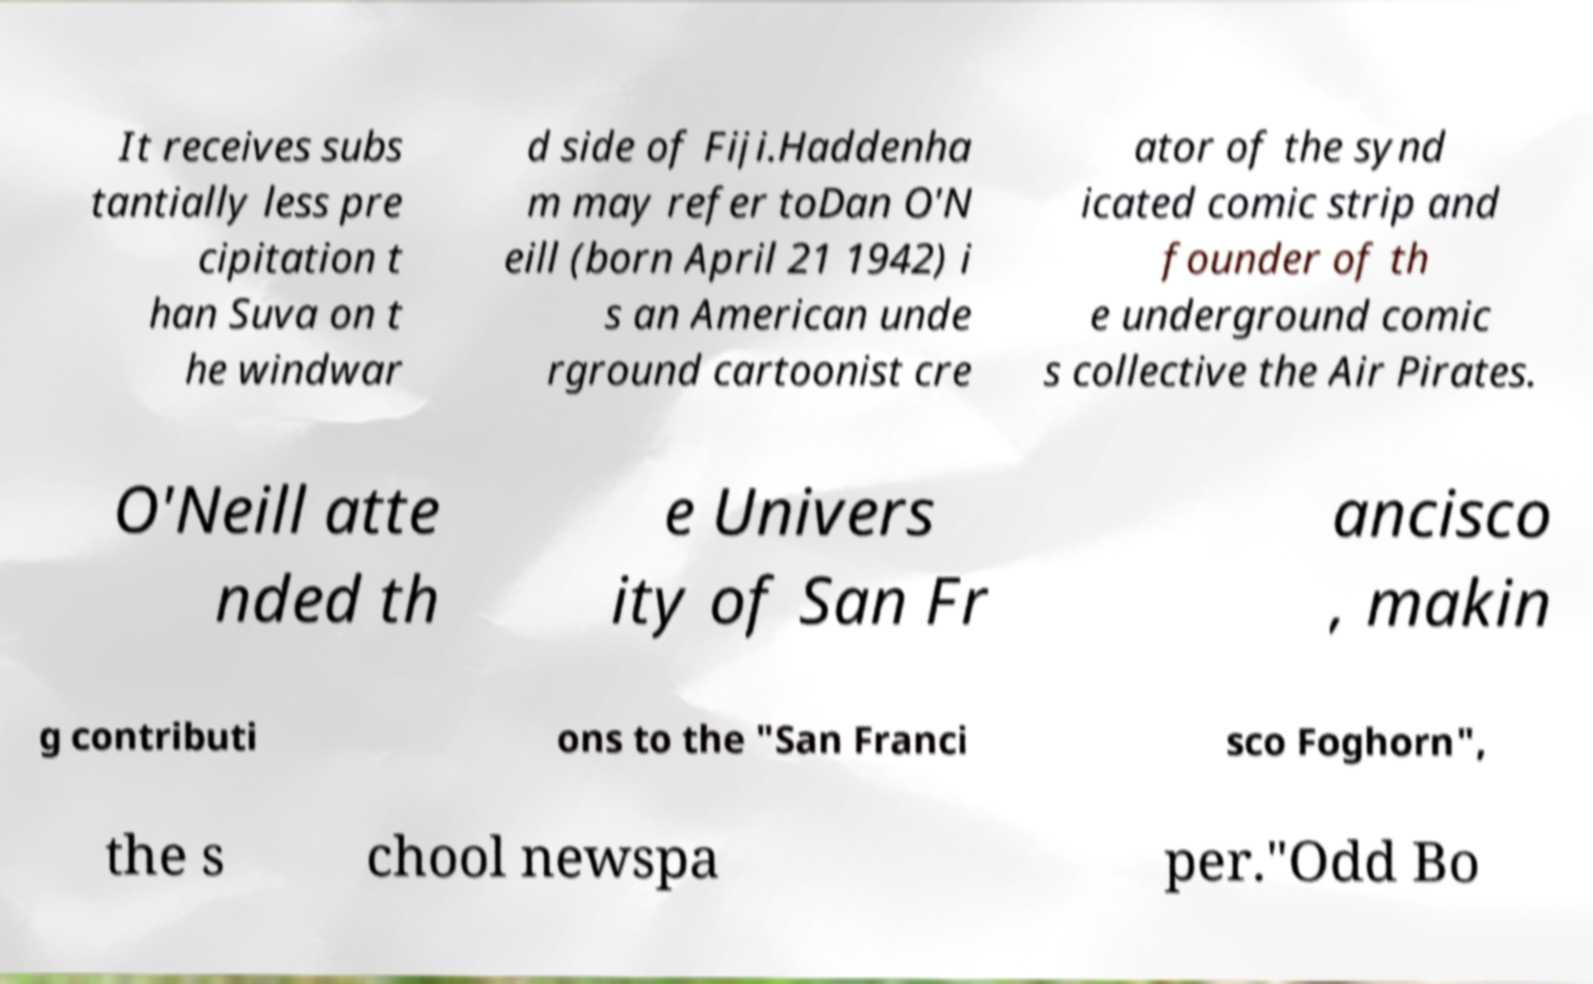Can you accurately transcribe the text from the provided image for me? It receives subs tantially less pre cipitation t han Suva on t he windwar d side of Fiji.Haddenha m may refer toDan O'N eill (born April 21 1942) i s an American unde rground cartoonist cre ator of the synd icated comic strip and founder of th e underground comic s collective the Air Pirates. O'Neill atte nded th e Univers ity of San Fr ancisco , makin g contributi ons to the "San Franci sco Foghorn", the s chool newspa per."Odd Bo 